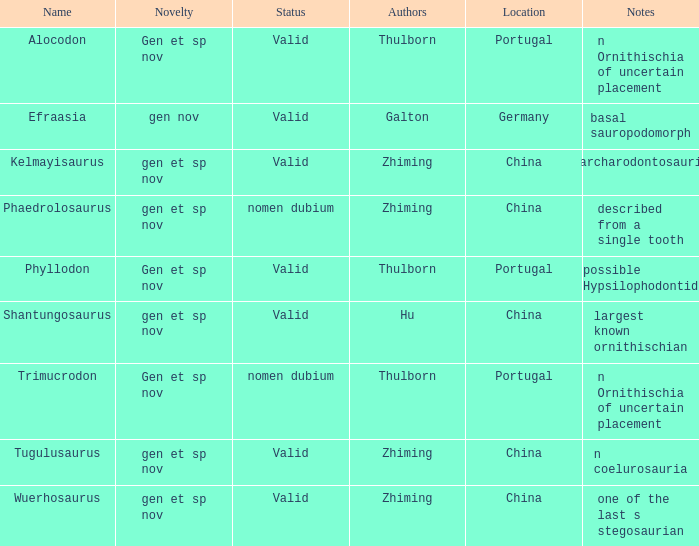What is the Novelty of the dinosaur that was named by the Author, Zhiming, and whose Notes are, "carcharodontosaurid"? Gen et sp nov. Parse the full table. {'header': ['Name', 'Novelty', 'Status', 'Authors', 'Location', 'Notes'], 'rows': [['Alocodon', 'Gen et sp nov', 'Valid', 'Thulborn', 'Portugal', 'n Ornithischia of uncertain placement'], ['Efraasia', 'gen nov', 'Valid', 'Galton', 'Germany', 'basal sauropodomorph'], ['Kelmayisaurus', 'gen et sp nov', 'Valid', 'Zhiming', 'China', 'carcharodontosaurid'], ['Phaedrolosaurus', 'gen et sp nov', 'nomen dubium', 'Zhiming', 'China', 'described from a single tooth'], ['Phyllodon', 'Gen et sp nov', 'Valid', 'Thulborn', 'Portugal', 'possible Hypsilophodontid'], ['Shantungosaurus', 'gen et sp nov', 'Valid', 'Hu', 'China', 'largest known ornithischian'], ['Trimucrodon', 'Gen et sp nov', 'nomen dubium', 'Thulborn', 'Portugal', 'n Ornithischia of uncertain placement'], ['Tugulusaurus', 'gen et sp nov', 'Valid', 'Zhiming', 'China', 'n coelurosauria'], ['Wuerhosaurus', 'gen et sp nov', 'Valid', 'Zhiming', 'China', 'one of the last s stegosaurian']]} 